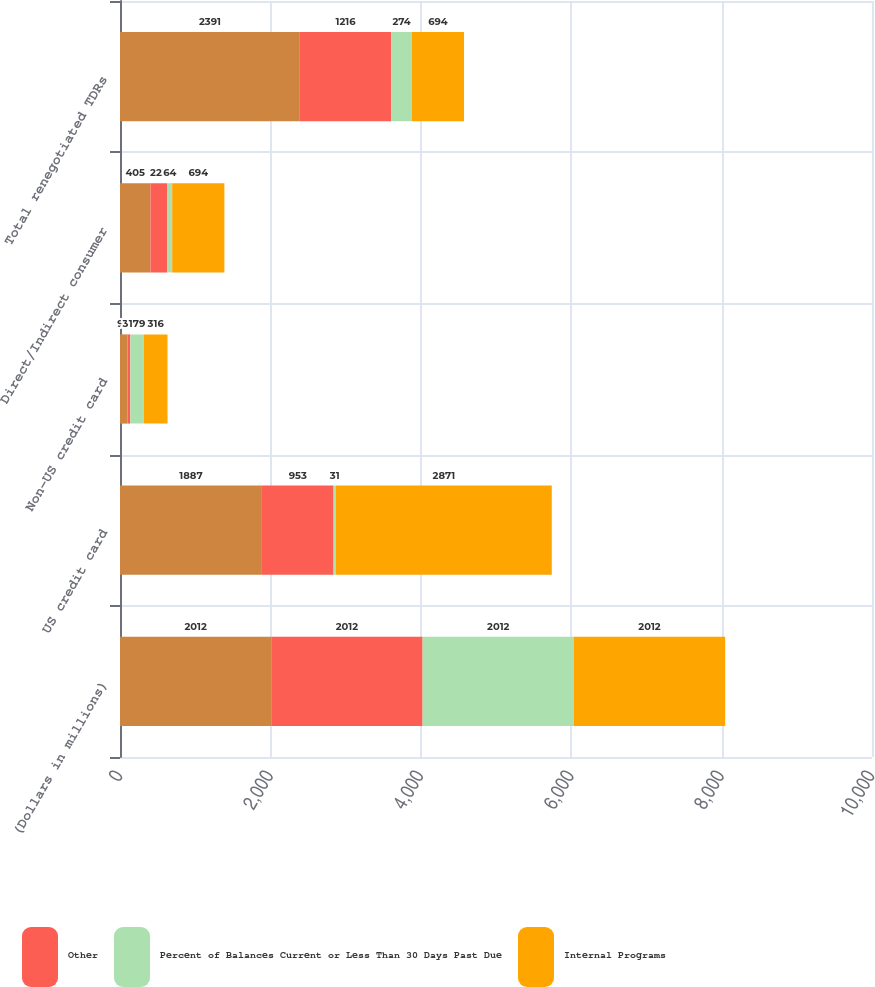Convert chart to OTSL. <chart><loc_0><loc_0><loc_500><loc_500><stacked_bar_chart><ecel><fcel>(Dollars in millions)<fcel>US credit card<fcel>Non-US credit card<fcel>Direct/Indirect consumer<fcel>Total renegotiated TDRs<nl><fcel>nan<fcel>2012<fcel>1887<fcel>99<fcel>405<fcel>2391<nl><fcel>Other<fcel>2012<fcel>953<fcel>38<fcel>225<fcel>1216<nl><fcel>Percent of Balances Current or Less Than 30 Days Past Due<fcel>2012<fcel>31<fcel>179<fcel>64<fcel>274<nl><fcel>Internal Programs<fcel>2012<fcel>2871<fcel>316<fcel>694<fcel>694<nl></chart> 